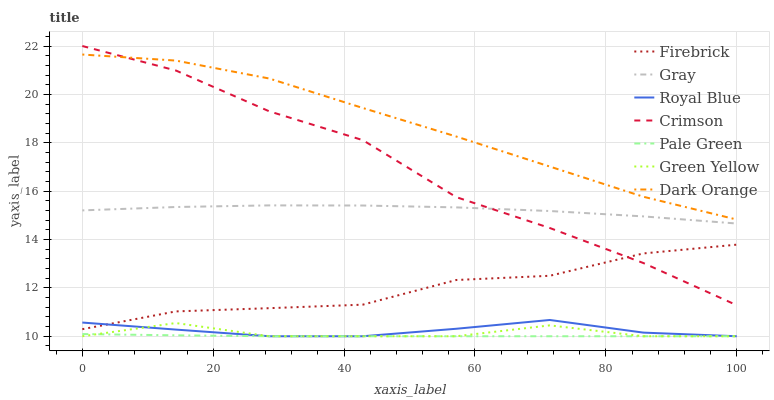Does Pale Green have the minimum area under the curve?
Answer yes or no. Yes. Does Dark Orange have the maximum area under the curve?
Answer yes or no. Yes. Does Firebrick have the minimum area under the curve?
Answer yes or no. No. Does Firebrick have the maximum area under the curve?
Answer yes or no. No. Is Pale Green the smoothest?
Answer yes or no. Yes. Is Crimson the roughest?
Answer yes or no. Yes. Is Dark Orange the smoothest?
Answer yes or no. No. Is Dark Orange the roughest?
Answer yes or no. No. Does Royal Blue have the lowest value?
Answer yes or no. Yes. Does Firebrick have the lowest value?
Answer yes or no. No. Does Crimson have the highest value?
Answer yes or no. Yes. Does Dark Orange have the highest value?
Answer yes or no. No. Is Royal Blue less than Crimson?
Answer yes or no. Yes. Is Gray greater than Royal Blue?
Answer yes or no. Yes. Does Royal Blue intersect Pale Green?
Answer yes or no. Yes. Is Royal Blue less than Pale Green?
Answer yes or no. No. Is Royal Blue greater than Pale Green?
Answer yes or no. No. Does Royal Blue intersect Crimson?
Answer yes or no. No. 